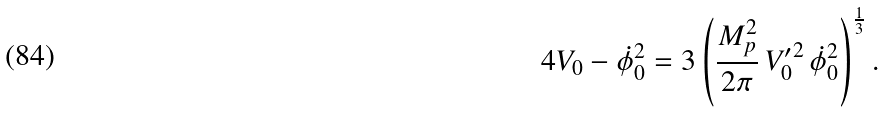Convert formula to latex. <formula><loc_0><loc_0><loc_500><loc_500>4 V _ { 0 } - \dot { \phi } _ { 0 } ^ { 2 } = 3 \left ( \frac { M _ { p } ^ { 2 } } { 2 \pi } \, { V _ { 0 } ^ { \prime } } ^ { 2 } \, \dot { \phi } _ { 0 } ^ { 2 } \right ) ^ { \frac { 1 } { 3 } } .</formula> 